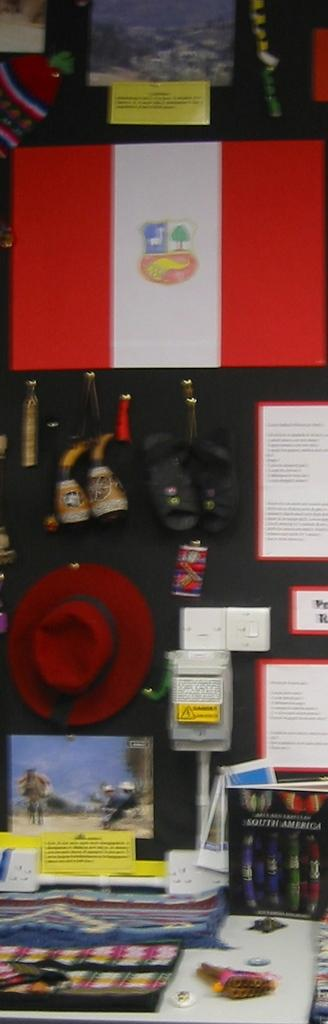What type of items can be seen on the walls in the image? There are posters in the image. What type of clothing accessory is visible in the image? There is a cap in the image. What other objects can be seen in the image besides the posters and cap? There are some unspecified objects in the image. How many tickets are visible in the image? There are no tickets present in the image. What type of son can be seen playing with a light in the image? There is no son or light present in the image. 